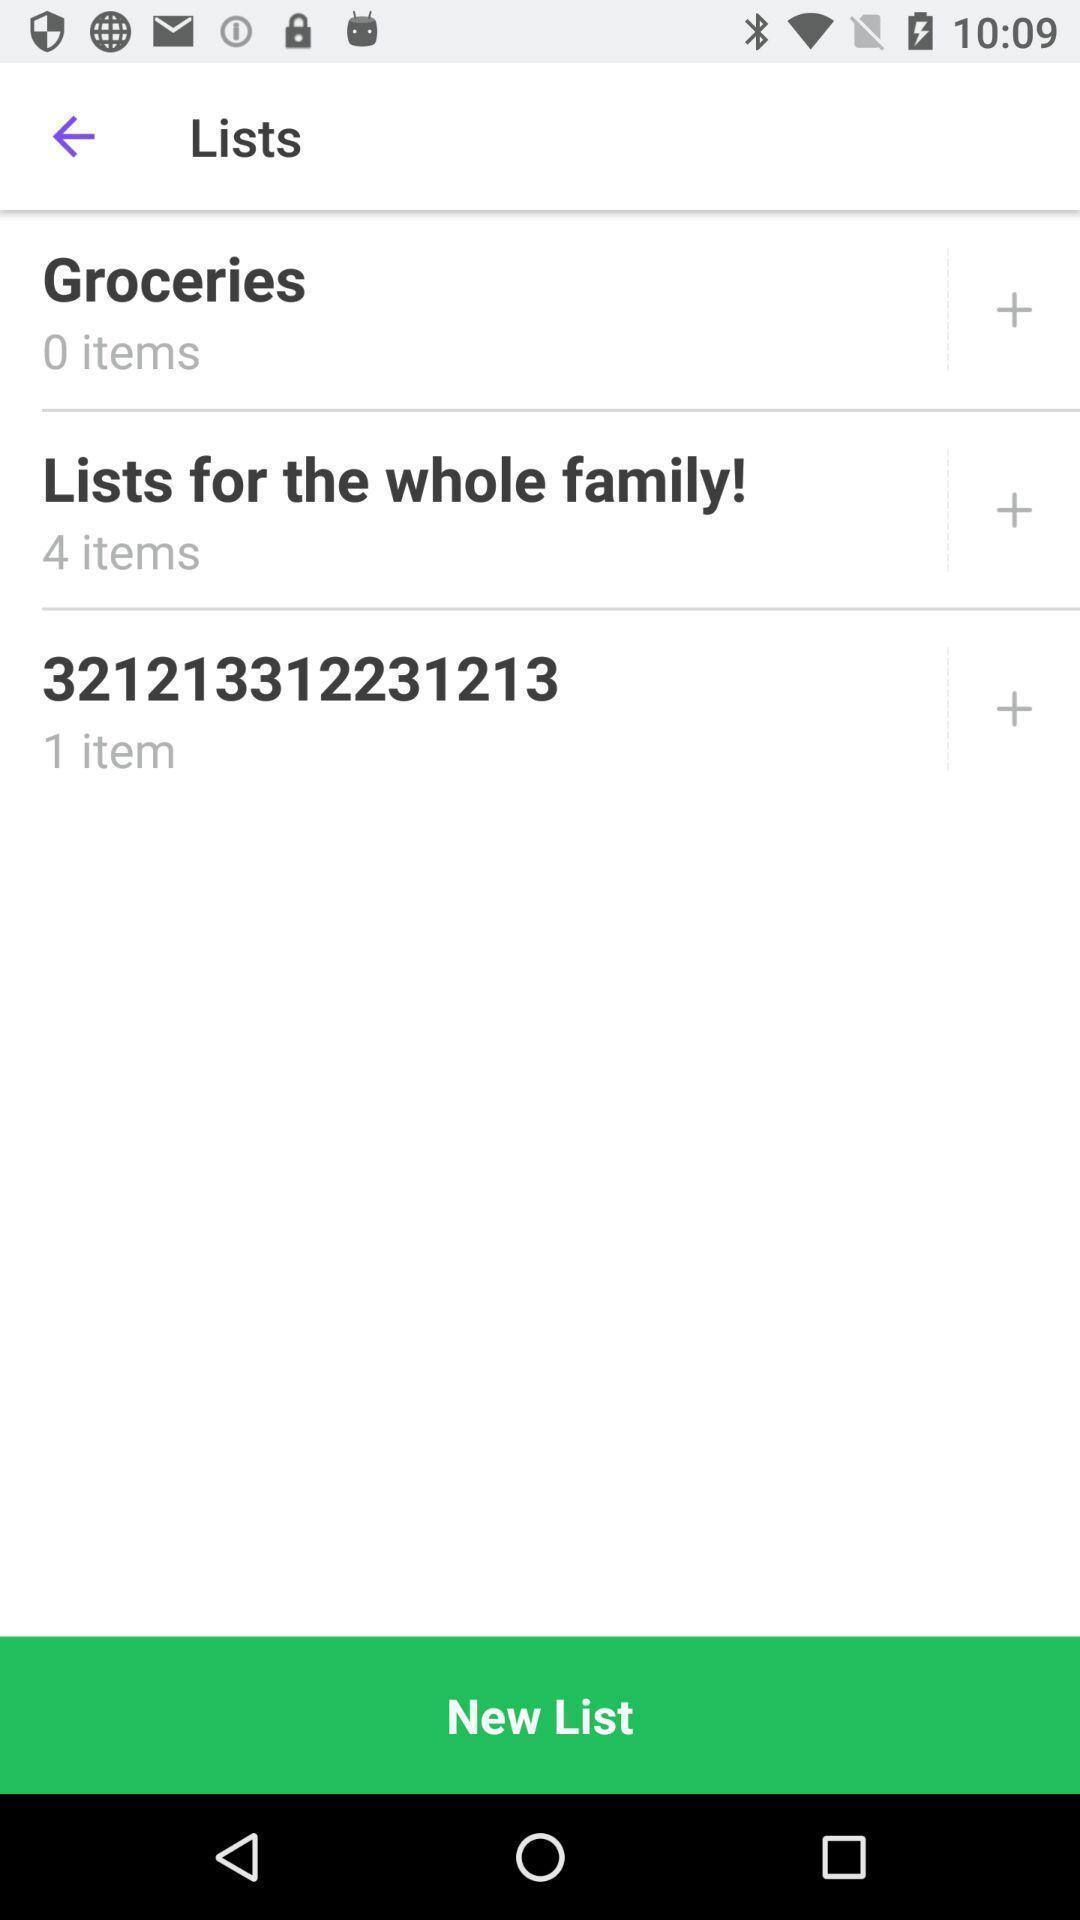Summarize the information in this screenshot. Page showing the options for groceries app. 